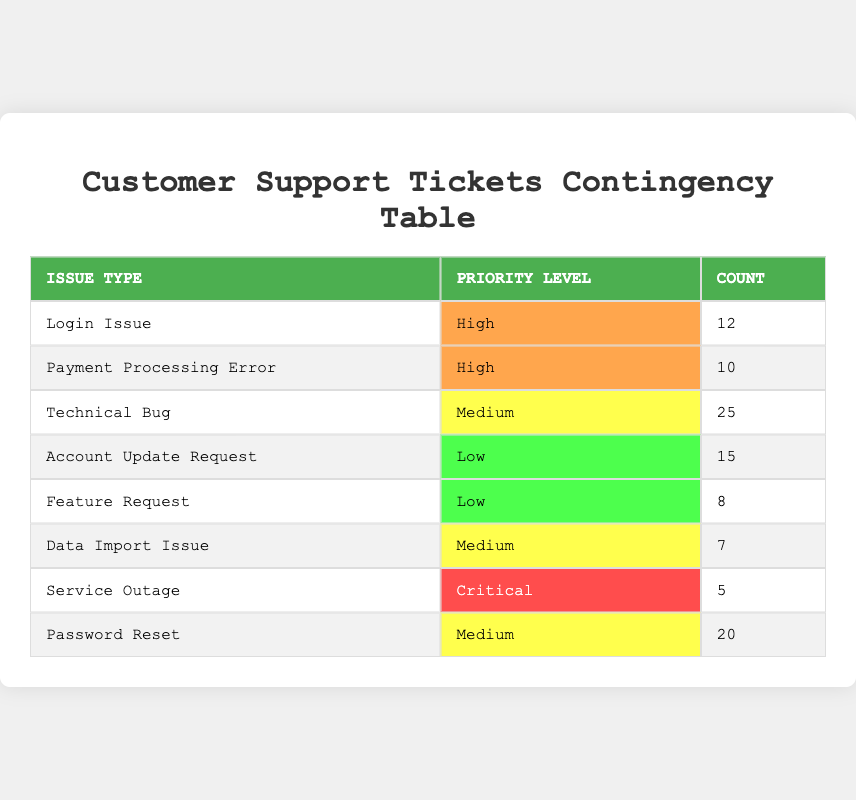What is the total count of tickets for "Technical Bug"? There is only one row in the table that lists "Technical Bug" as the issue type, and its count is clearly stated in that row as 25.
Answer: 25 How many tickets are categorized as "High" priority? There are two rows with "High" priority: "Login Issue" (12) and "Payment Processing Error" (10). Summing these values gives 12 + 10 = 22.
Answer: 22 Is there any issue type categorized as "Critical"? The table includes a row with "Service Outage" labeled as "Critical." Therefore, it confirms the presence of a critical issue.
Answer: Yes What issue type has the highest number of tickets? The issue type with the highest count is "Technical Bug," which has a total of 25 tickets. This is more than any other issue type listed in the table.
Answer: Technical Bug What is the difference in count between "Password Reset" and "Data Import Issue"? The count for "Password Reset" is 20, and for "Data Import Issue," it is 7. To find the difference, we subtract: 20 - 7 = 13.
Answer: 13 What percentage of the total tickets are represented by "Account Update Request"? Calculating the total tickets: 12 + 10 + 25 + 15 + 8 + 7 + 5 + 20 = 77. The count for "Account Update Request" is 15. The percentage is (15/77) * 100, which is approximately 19.48%.
Answer: 19.48% How many more tickets are there for "Medium" priority issues than "Low" priority issues combined? There are three "Medium" priority tickets counts: "Technical Bug" (25), "Data Import Issue" (7), and "Password Reset" (20). Summing these gives 25 + 7 + 20 = 52. The "Low" priority counts are "Account Update Request" (15) and "Feature Request" (8), summing to 15 + 8 = 23. The difference is 52 - 23 = 29.
Answer: 29 Is the count of "Payment Processing Error" higher than "Service Outage"? The count for "Payment Processing Error" is 10, while for "Service Outage," it is 5. Since 10 is greater than 5, this statement is true.
Answer: Yes Which priority level has the least number of tickets? By examining the counts in the table, "Critical" with 5 tickets has the least count compared to other priority levels.
Answer: Critical 